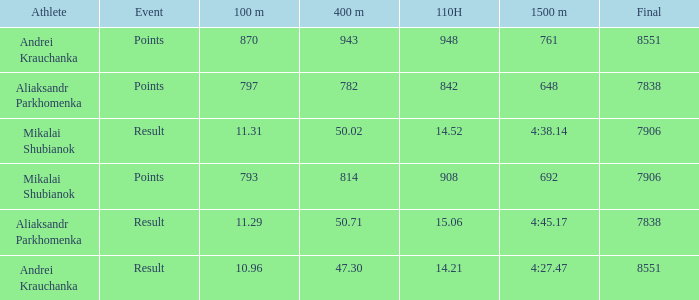What was the final for Mikalai Shubianok who had a 110H less than 908? 7906.0. 